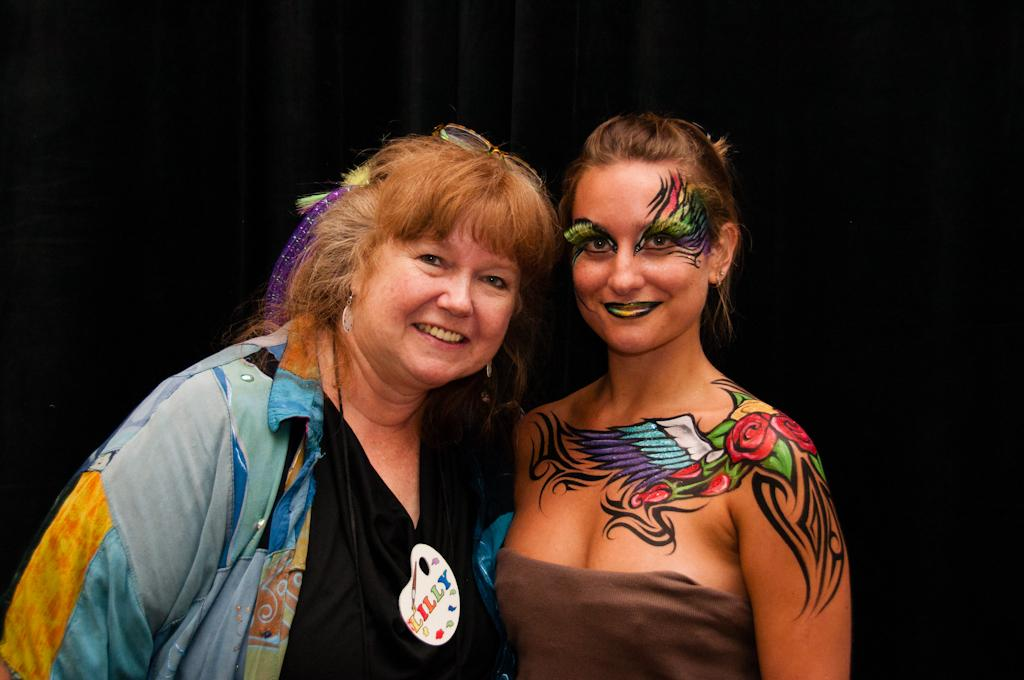How many people are in the image? There are two women in the image. What are the women doing in the image? The women are standing and giving a pose for the picture. What is the facial expression of the women in the image? The women are smiling in the image. What is the color of the background in the image? The background of the image is black. How much attention does the sugar receive in the image? There is no sugar present in the image, so it cannot receive any attention. 